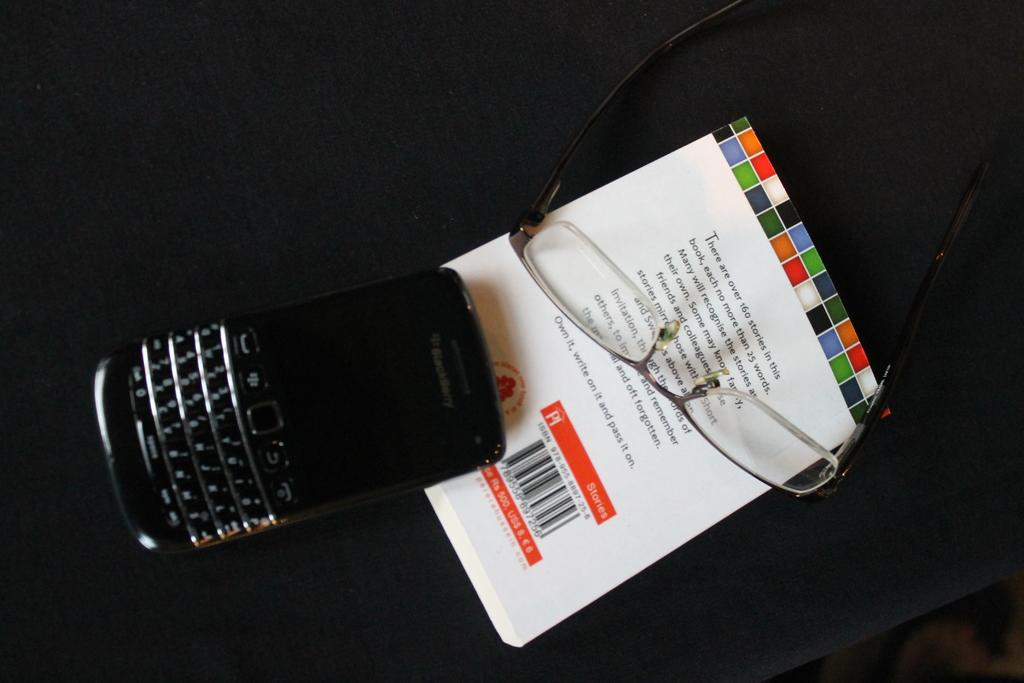<image>
Provide a brief description of the given image. A Blackberry phone sits next to a small book and a pair of glasses. 